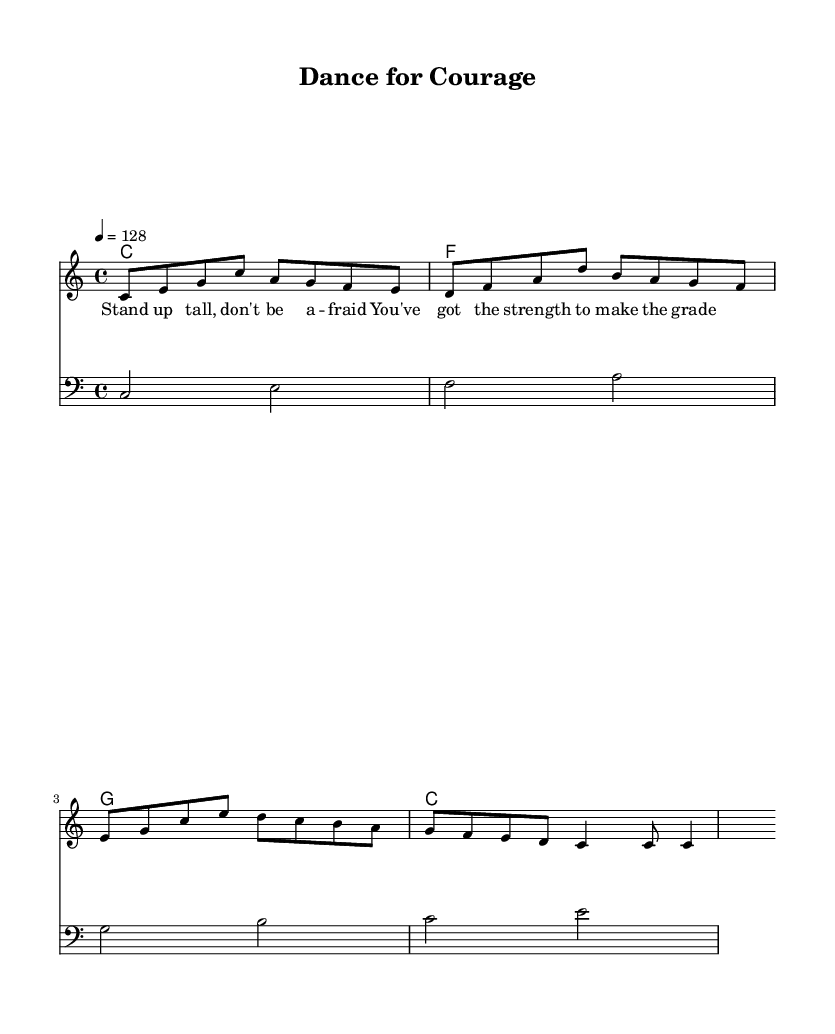What is the key signature of this music? The key signature is indicated at the beginning of the piece and shows no sharps or flats, which corresponds to the key of C major.
Answer: C major What is the time signature of this music? The time signature is shown as a fraction at the beginning of the piece, which reads 4/4, meaning there are four beats per measure.
Answer: 4/4 What is the tempo marking of this music? The tempo marking is indicated as "4 = 128," which specifies that there are 128 beats per minute (BPM).
Answer: 128 How many measures are there in the melody? By counting the measures in the melody line, which are separated by vertical lines, we find a total of four measures.
Answer: 4 What is the first note in the melody? The first note of the melody is the pitch represented by the note on the staff which corresponds to middle C.
Answer: C What type of dance does this music represent? The upbeat tempo and rhythmic structure, in addition to the positive lyrics, suggest that this music is intended for energetic dance.
Answer: Energetic dance What is the last lyric in the text? The lyrics are indicated beneath the melody and the last line concludes with the word "grade."
Answer: grade 